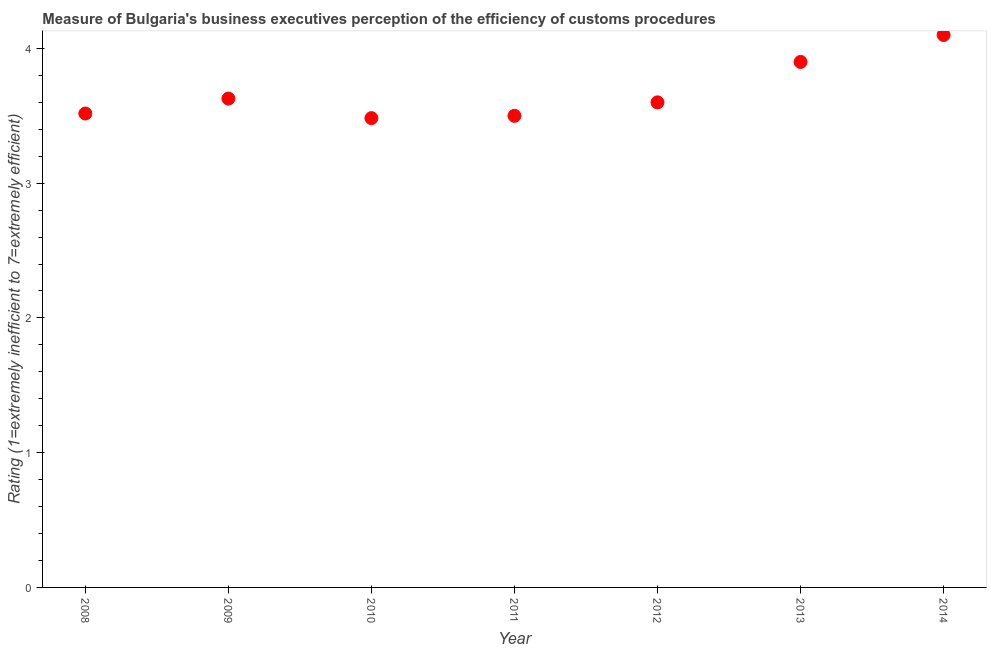Across all years, what is the minimum rating measuring burden of customs procedure?
Offer a very short reply. 3.48. In which year was the rating measuring burden of customs procedure maximum?
Provide a short and direct response. 2014. What is the sum of the rating measuring burden of customs procedure?
Give a very brief answer. 25.73. What is the difference between the rating measuring burden of customs procedure in 2012 and 2013?
Provide a succinct answer. -0.3. What is the average rating measuring burden of customs procedure per year?
Your response must be concise. 3.68. What is the median rating measuring burden of customs procedure?
Your answer should be very brief. 3.6. What is the ratio of the rating measuring burden of customs procedure in 2010 to that in 2013?
Your answer should be very brief. 0.89. Is the rating measuring burden of customs procedure in 2008 less than that in 2013?
Offer a very short reply. Yes. What is the difference between the highest and the second highest rating measuring burden of customs procedure?
Provide a short and direct response. 0.2. What is the difference between the highest and the lowest rating measuring burden of customs procedure?
Your answer should be very brief. 0.62. In how many years, is the rating measuring burden of customs procedure greater than the average rating measuring burden of customs procedure taken over all years?
Offer a very short reply. 2. How many years are there in the graph?
Offer a very short reply. 7. What is the difference between two consecutive major ticks on the Y-axis?
Your answer should be compact. 1. Are the values on the major ticks of Y-axis written in scientific E-notation?
Your answer should be compact. No. Does the graph contain any zero values?
Make the answer very short. No. Does the graph contain grids?
Offer a terse response. No. What is the title of the graph?
Your answer should be very brief. Measure of Bulgaria's business executives perception of the efficiency of customs procedures. What is the label or title of the Y-axis?
Offer a very short reply. Rating (1=extremely inefficient to 7=extremely efficient). What is the Rating (1=extremely inefficient to 7=extremely efficient) in 2008?
Offer a very short reply. 3.52. What is the Rating (1=extremely inefficient to 7=extremely efficient) in 2009?
Give a very brief answer. 3.63. What is the Rating (1=extremely inefficient to 7=extremely efficient) in 2010?
Keep it short and to the point. 3.48. What is the Rating (1=extremely inefficient to 7=extremely efficient) in 2012?
Offer a very short reply. 3.6. What is the Rating (1=extremely inefficient to 7=extremely efficient) in 2013?
Your response must be concise. 3.9. What is the difference between the Rating (1=extremely inefficient to 7=extremely efficient) in 2008 and 2009?
Offer a terse response. -0.11. What is the difference between the Rating (1=extremely inefficient to 7=extremely efficient) in 2008 and 2010?
Offer a very short reply. 0.03. What is the difference between the Rating (1=extremely inefficient to 7=extremely efficient) in 2008 and 2011?
Your response must be concise. 0.02. What is the difference between the Rating (1=extremely inefficient to 7=extremely efficient) in 2008 and 2012?
Offer a terse response. -0.08. What is the difference between the Rating (1=extremely inefficient to 7=extremely efficient) in 2008 and 2013?
Your answer should be compact. -0.38. What is the difference between the Rating (1=extremely inefficient to 7=extremely efficient) in 2008 and 2014?
Provide a succinct answer. -0.58. What is the difference between the Rating (1=extremely inefficient to 7=extremely efficient) in 2009 and 2010?
Your response must be concise. 0.14. What is the difference between the Rating (1=extremely inefficient to 7=extremely efficient) in 2009 and 2011?
Offer a very short reply. 0.13. What is the difference between the Rating (1=extremely inefficient to 7=extremely efficient) in 2009 and 2012?
Your answer should be very brief. 0.03. What is the difference between the Rating (1=extremely inefficient to 7=extremely efficient) in 2009 and 2013?
Your response must be concise. -0.27. What is the difference between the Rating (1=extremely inefficient to 7=extremely efficient) in 2009 and 2014?
Your answer should be very brief. -0.47. What is the difference between the Rating (1=extremely inefficient to 7=extremely efficient) in 2010 and 2011?
Your response must be concise. -0.02. What is the difference between the Rating (1=extremely inefficient to 7=extremely efficient) in 2010 and 2012?
Provide a short and direct response. -0.12. What is the difference between the Rating (1=extremely inefficient to 7=extremely efficient) in 2010 and 2013?
Offer a very short reply. -0.42. What is the difference between the Rating (1=extremely inefficient to 7=extremely efficient) in 2010 and 2014?
Ensure brevity in your answer.  -0.62. What is the difference between the Rating (1=extremely inefficient to 7=extremely efficient) in 2011 and 2013?
Give a very brief answer. -0.4. What is the difference between the Rating (1=extremely inefficient to 7=extremely efficient) in 2012 and 2013?
Your answer should be very brief. -0.3. What is the difference between the Rating (1=extremely inefficient to 7=extremely efficient) in 2012 and 2014?
Offer a very short reply. -0.5. What is the difference between the Rating (1=extremely inefficient to 7=extremely efficient) in 2013 and 2014?
Offer a very short reply. -0.2. What is the ratio of the Rating (1=extremely inefficient to 7=extremely efficient) in 2008 to that in 2010?
Your answer should be compact. 1.01. What is the ratio of the Rating (1=extremely inefficient to 7=extremely efficient) in 2008 to that in 2011?
Your answer should be very brief. 1. What is the ratio of the Rating (1=extremely inefficient to 7=extremely efficient) in 2008 to that in 2013?
Make the answer very short. 0.9. What is the ratio of the Rating (1=extremely inefficient to 7=extremely efficient) in 2008 to that in 2014?
Give a very brief answer. 0.86. What is the ratio of the Rating (1=extremely inefficient to 7=extremely efficient) in 2009 to that in 2010?
Give a very brief answer. 1.04. What is the ratio of the Rating (1=extremely inefficient to 7=extremely efficient) in 2009 to that in 2011?
Offer a very short reply. 1.04. What is the ratio of the Rating (1=extremely inefficient to 7=extremely efficient) in 2009 to that in 2012?
Your response must be concise. 1.01. What is the ratio of the Rating (1=extremely inefficient to 7=extremely efficient) in 2009 to that in 2013?
Give a very brief answer. 0.93. What is the ratio of the Rating (1=extremely inefficient to 7=extremely efficient) in 2009 to that in 2014?
Provide a short and direct response. 0.89. What is the ratio of the Rating (1=extremely inefficient to 7=extremely efficient) in 2010 to that in 2011?
Offer a very short reply. 0.99. What is the ratio of the Rating (1=extremely inefficient to 7=extremely efficient) in 2010 to that in 2012?
Keep it short and to the point. 0.97. What is the ratio of the Rating (1=extremely inefficient to 7=extremely efficient) in 2010 to that in 2013?
Provide a short and direct response. 0.89. What is the ratio of the Rating (1=extremely inefficient to 7=extremely efficient) in 2011 to that in 2013?
Offer a very short reply. 0.9. What is the ratio of the Rating (1=extremely inefficient to 7=extremely efficient) in 2011 to that in 2014?
Provide a short and direct response. 0.85. What is the ratio of the Rating (1=extremely inefficient to 7=extremely efficient) in 2012 to that in 2013?
Keep it short and to the point. 0.92. What is the ratio of the Rating (1=extremely inefficient to 7=extremely efficient) in 2012 to that in 2014?
Keep it short and to the point. 0.88. What is the ratio of the Rating (1=extremely inefficient to 7=extremely efficient) in 2013 to that in 2014?
Give a very brief answer. 0.95. 